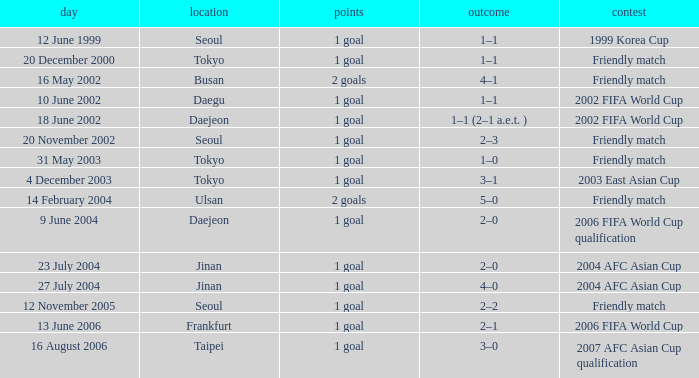What is the competition that occured on 27 July 2004? 2004 AFC Asian Cup. 